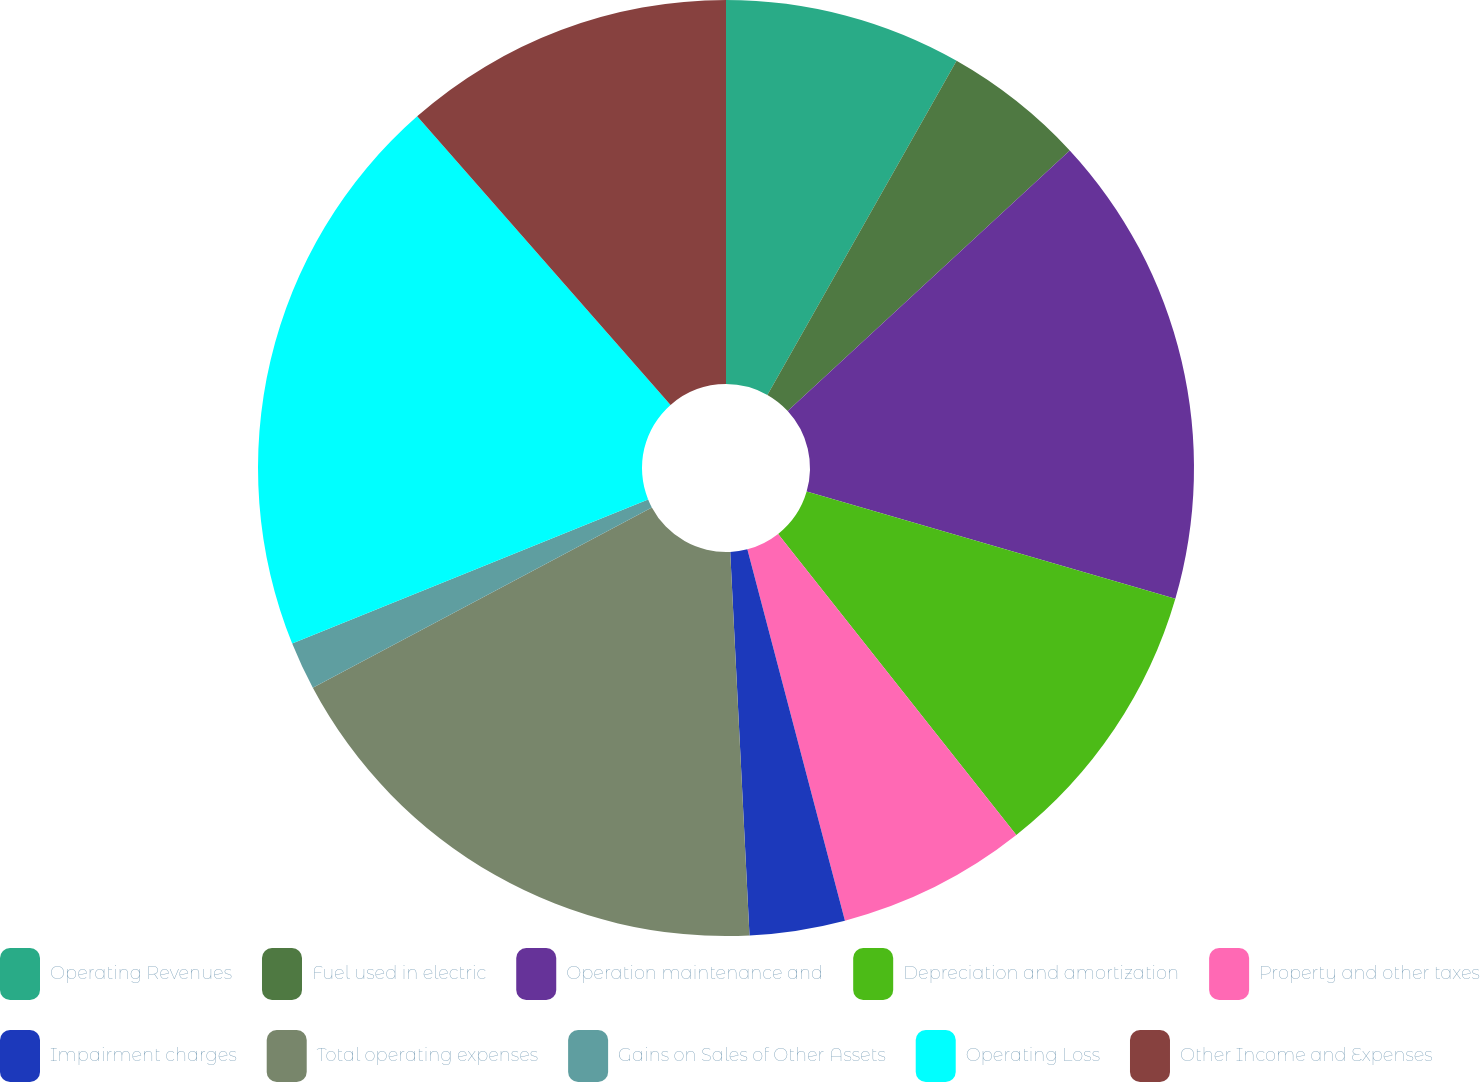Convert chart to OTSL. <chart><loc_0><loc_0><loc_500><loc_500><pie_chart><fcel>Operating Revenues<fcel>Fuel used in electric<fcel>Operation maintenance and<fcel>Depreciation and amortization<fcel>Property and other taxes<fcel>Impairment charges<fcel>Total operating expenses<fcel>Gains on Sales of Other Assets<fcel>Operating Loss<fcel>Other Income and Expenses<nl><fcel>8.2%<fcel>4.93%<fcel>16.38%<fcel>9.84%<fcel>6.56%<fcel>3.29%<fcel>18.02%<fcel>1.66%<fcel>19.65%<fcel>11.47%<nl></chart> 